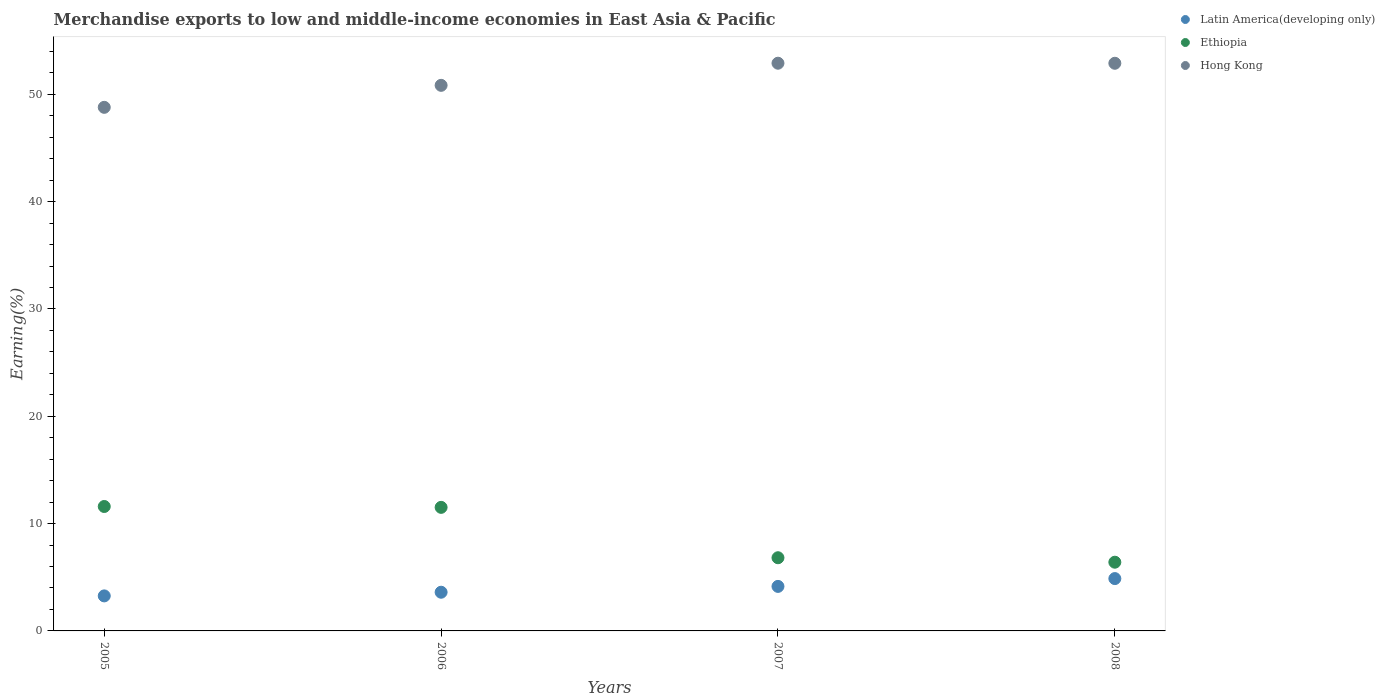What is the percentage of amount earned from merchandise exports in Ethiopia in 2006?
Keep it short and to the point. 11.51. Across all years, what is the maximum percentage of amount earned from merchandise exports in Hong Kong?
Your response must be concise. 52.91. Across all years, what is the minimum percentage of amount earned from merchandise exports in Ethiopia?
Keep it short and to the point. 6.4. In which year was the percentage of amount earned from merchandise exports in Ethiopia maximum?
Offer a very short reply. 2005. In which year was the percentage of amount earned from merchandise exports in Hong Kong minimum?
Make the answer very short. 2005. What is the total percentage of amount earned from merchandise exports in Latin America(developing only) in the graph?
Provide a short and direct response. 15.9. What is the difference between the percentage of amount earned from merchandise exports in Hong Kong in 2005 and that in 2008?
Provide a short and direct response. -4.11. What is the difference between the percentage of amount earned from merchandise exports in Ethiopia in 2005 and the percentage of amount earned from merchandise exports in Latin America(developing only) in 2008?
Keep it short and to the point. 6.72. What is the average percentage of amount earned from merchandise exports in Ethiopia per year?
Keep it short and to the point. 9.08. In the year 2005, what is the difference between the percentage of amount earned from merchandise exports in Hong Kong and percentage of amount earned from merchandise exports in Latin America(developing only)?
Offer a terse response. 45.53. In how many years, is the percentage of amount earned from merchandise exports in Hong Kong greater than 26 %?
Keep it short and to the point. 4. What is the ratio of the percentage of amount earned from merchandise exports in Hong Kong in 2005 to that in 2006?
Make the answer very short. 0.96. Is the percentage of amount earned from merchandise exports in Hong Kong in 2005 less than that in 2006?
Your response must be concise. Yes. What is the difference between the highest and the second highest percentage of amount earned from merchandise exports in Hong Kong?
Give a very brief answer. 0.01. What is the difference between the highest and the lowest percentage of amount earned from merchandise exports in Latin America(developing only)?
Provide a short and direct response. 1.61. In how many years, is the percentage of amount earned from merchandise exports in Latin America(developing only) greater than the average percentage of amount earned from merchandise exports in Latin America(developing only) taken over all years?
Your answer should be compact. 2. Is the percentage of amount earned from merchandise exports in Hong Kong strictly less than the percentage of amount earned from merchandise exports in Ethiopia over the years?
Give a very brief answer. No. How many dotlines are there?
Your response must be concise. 3. How many years are there in the graph?
Offer a very short reply. 4. Does the graph contain any zero values?
Offer a terse response. No. Does the graph contain grids?
Offer a very short reply. No. How are the legend labels stacked?
Provide a short and direct response. Vertical. What is the title of the graph?
Make the answer very short. Merchandise exports to low and middle-income economies in East Asia & Pacific. What is the label or title of the X-axis?
Provide a short and direct response. Years. What is the label or title of the Y-axis?
Provide a succinct answer. Earning(%). What is the Earning(%) in Latin America(developing only) in 2005?
Offer a terse response. 3.26. What is the Earning(%) in Ethiopia in 2005?
Keep it short and to the point. 11.6. What is the Earning(%) in Hong Kong in 2005?
Keep it short and to the point. 48.79. What is the Earning(%) of Latin America(developing only) in 2006?
Provide a short and direct response. 3.61. What is the Earning(%) in Ethiopia in 2006?
Give a very brief answer. 11.51. What is the Earning(%) of Hong Kong in 2006?
Give a very brief answer. 50.84. What is the Earning(%) of Latin America(developing only) in 2007?
Your answer should be compact. 4.15. What is the Earning(%) of Ethiopia in 2007?
Give a very brief answer. 6.82. What is the Earning(%) of Hong Kong in 2007?
Provide a short and direct response. 52.91. What is the Earning(%) in Latin America(developing only) in 2008?
Your answer should be very brief. 4.88. What is the Earning(%) of Ethiopia in 2008?
Offer a very short reply. 6.4. What is the Earning(%) in Hong Kong in 2008?
Offer a terse response. 52.9. Across all years, what is the maximum Earning(%) of Latin America(developing only)?
Your response must be concise. 4.88. Across all years, what is the maximum Earning(%) in Ethiopia?
Provide a succinct answer. 11.6. Across all years, what is the maximum Earning(%) in Hong Kong?
Provide a succinct answer. 52.91. Across all years, what is the minimum Earning(%) of Latin America(developing only)?
Keep it short and to the point. 3.26. Across all years, what is the minimum Earning(%) of Ethiopia?
Provide a succinct answer. 6.4. Across all years, what is the minimum Earning(%) of Hong Kong?
Provide a short and direct response. 48.79. What is the total Earning(%) in Latin America(developing only) in the graph?
Your answer should be very brief. 15.9. What is the total Earning(%) in Ethiopia in the graph?
Your answer should be very brief. 36.33. What is the total Earning(%) of Hong Kong in the graph?
Ensure brevity in your answer.  205.44. What is the difference between the Earning(%) of Latin America(developing only) in 2005 and that in 2006?
Give a very brief answer. -0.34. What is the difference between the Earning(%) in Ethiopia in 2005 and that in 2006?
Provide a short and direct response. 0.08. What is the difference between the Earning(%) of Hong Kong in 2005 and that in 2006?
Your answer should be very brief. -2.05. What is the difference between the Earning(%) in Latin America(developing only) in 2005 and that in 2007?
Ensure brevity in your answer.  -0.88. What is the difference between the Earning(%) in Ethiopia in 2005 and that in 2007?
Keep it short and to the point. 4.78. What is the difference between the Earning(%) in Hong Kong in 2005 and that in 2007?
Ensure brevity in your answer.  -4.11. What is the difference between the Earning(%) of Latin America(developing only) in 2005 and that in 2008?
Your answer should be very brief. -1.61. What is the difference between the Earning(%) in Ethiopia in 2005 and that in 2008?
Ensure brevity in your answer.  5.19. What is the difference between the Earning(%) of Hong Kong in 2005 and that in 2008?
Your answer should be compact. -4.11. What is the difference between the Earning(%) of Latin America(developing only) in 2006 and that in 2007?
Ensure brevity in your answer.  -0.54. What is the difference between the Earning(%) of Ethiopia in 2006 and that in 2007?
Provide a succinct answer. 4.7. What is the difference between the Earning(%) in Hong Kong in 2006 and that in 2007?
Give a very brief answer. -2.06. What is the difference between the Earning(%) of Latin America(developing only) in 2006 and that in 2008?
Keep it short and to the point. -1.27. What is the difference between the Earning(%) in Ethiopia in 2006 and that in 2008?
Ensure brevity in your answer.  5.11. What is the difference between the Earning(%) of Hong Kong in 2006 and that in 2008?
Your answer should be very brief. -2.06. What is the difference between the Earning(%) in Latin America(developing only) in 2007 and that in 2008?
Provide a succinct answer. -0.73. What is the difference between the Earning(%) in Ethiopia in 2007 and that in 2008?
Your answer should be very brief. 0.42. What is the difference between the Earning(%) of Hong Kong in 2007 and that in 2008?
Make the answer very short. 0.01. What is the difference between the Earning(%) of Latin America(developing only) in 2005 and the Earning(%) of Ethiopia in 2006?
Provide a short and direct response. -8.25. What is the difference between the Earning(%) of Latin America(developing only) in 2005 and the Earning(%) of Hong Kong in 2006?
Ensure brevity in your answer.  -47.58. What is the difference between the Earning(%) of Ethiopia in 2005 and the Earning(%) of Hong Kong in 2006?
Provide a succinct answer. -39.25. What is the difference between the Earning(%) in Latin America(developing only) in 2005 and the Earning(%) in Ethiopia in 2007?
Give a very brief answer. -3.56. What is the difference between the Earning(%) of Latin America(developing only) in 2005 and the Earning(%) of Hong Kong in 2007?
Ensure brevity in your answer.  -49.64. What is the difference between the Earning(%) in Ethiopia in 2005 and the Earning(%) in Hong Kong in 2007?
Offer a very short reply. -41.31. What is the difference between the Earning(%) of Latin America(developing only) in 2005 and the Earning(%) of Ethiopia in 2008?
Provide a succinct answer. -3.14. What is the difference between the Earning(%) of Latin America(developing only) in 2005 and the Earning(%) of Hong Kong in 2008?
Provide a succinct answer. -49.64. What is the difference between the Earning(%) in Ethiopia in 2005 and the Earning(%) in Hong Kong in 2008?
Your answer should be compact. -41.3. What is the difference between the Earning(%) in Latin America(developing only) in 2006 and the Earning(%) in Ethiopia in 2007?
Provide a succinct answer. -3.21. What is the difference between the Earning(%) of Latin America(developing only) in 2006 and the Earning(%) of Hong Kong in 2007?
Your answer should be compact. -49.3. What is the difference between the Earning(%) in Ethiopia in 2006 and the Earning(%) in Hong Kong in 2007?
Your answer should be very brief. -41.39. What is the difference between the Earning(%) of Latin America(developing only) in 2006 and the Earning(%) of Ethiopia in 2008?
Ensure brevity in your answer.  -2.8. What is the difference between the Earning(%) of Latin America(developing only) in 2006 and the Earning(%) of Hong Kong in 2008?
Offer a terse response. -49.29. What is the difference between the Earning(%) of Ethiopia in 2006 and the Earning(%) of Hong Kong in 2008?
Your response must be concise. -41.38. What is the difference between the Earning(%) of Latin America(developing only) in 2007 and the Earning(%) of Ethiopia in 2008?
Offer a terse response. -2.25. What is the difference between the Earning(%) in Latin America(developing only) in 2007 and the Earning(%) in Hong Kong in 2008?
Offer a very short reply. -48.75. What is the difference between the Earning(%) of Ethiopia in 2007 and the Earning(%) of Hong Kong in 2008?
Give a very brief answer. -46.08. What is the average Earning(%) in Latin America(developing only) per year?
Your answer should be very brief. 3.97. What is the average Earning(%) of Ethiopia per year?
Offer a terse response. 9.08. What is the average Earning(%) of Hong Kong per year?
Offer a very short reply. 51.36. In the year 2005, what is the difference between the Earning(%) in Latin America(developing only) and Earning(%) in Ethiopia?
Your answer should be very brief. -8.33. In the year 2005, what is the difference between the Earning(%) of Latin America(developing only) and Earning(%) of Hong Kong?
Offer a very short reply. -45.53. In the year 2005, what is the difference between the Earning(%) of Ethiopia and Earning(%) of Hong Kong?
Make the answer very short. -37.2. In the year 2006, what is the difference between the Earning(%) of Latin America(developing only) and Earning(%) of Ethiopia?
Give a very brief answer. -7.91. In the year 2006, what is the difference between the Earning(%) in Latin America(developing only) and Earning(%) in Hong Kong?
Ensure brevity in your answer.  -47.24. In the year 2006, what is the difference between the Earning(%) in Ethiopia and Earning(%) in Hong Kong?
Your answer should be very brief. -39.33. In the year 2007, what is the difference between the Earning(%) in Latin America(developing only) and Earning(%) in Ethiopia?
Ensure brevity in your answer.  -2.67. In the year 2007, what is the difference between the Earning(%) in Latin America(developing only) and Earning(%) in Hong Kong?
Keep it short and to the point. -48.76. In the year 2007, what is the difference between the Earning(%) of Ethiopia and Earning(%) of Hong Kong?
Provide a short and direct response. -46.09. In the year 2008, what is the difference between the Earning(%) in Latin America(developing only) and Earning(%) in Ethiopia?
Provide a succinct answer. -1.53. In the year 2008, what is the difference between the Earning(%) of Latin America(developing only) and Earning(%) of Hong Kong?
Give a very brief answer. -48.02. In the year 2008, what is the difference between the Earning(%) in Ethiopia and Earning(%) in Hong Kong?
Ensure brevity in your answer.  -46.5. What is the ratio of the Earning(%) in Latin America(developing only) in 2005 to that in 2006?
Give a very brief answer. 0.91. What is the ratio of the Earning(%) of Hong Kong in 2005 to that in 2006?
Provide a succinct answer. 0.96. What is the ratio of the Earning(%) in Latin America(developing only) in 2005 to that in 2007?
Ensure brevity in your answer.  0.79. What is the ratio of the Earning(%) in Ethiopia in 2005 to that in 2007?
Provide a succinct answer. 1.7. What is the ratio of the Earning(%) in Hong Kong in 2005 to that in 2007?
Offer a terse response. 0.92. What is the ratio of the Earning(%) in Latin America(developing only) in 2005 to that in 2008?
Provide a short and direct response. 0.67. What is the ratio of the Earning(%) of Ethiopia in 2005 to that in 2008?
Give a very brief answer. 1.81. What is the ratio of the Earning(%) in Hong Kong in 2005 to that in 2008?
Your response must be concise. 0.92. What is the ratio of the Earning(%) in Latin America(developing only) in 2006 to that in 2007?
Ensure brevity in your answer.  0.87. What is the ratio of the Earning(%) in Ethiopia in 2006 to that in 2007?
Make the answer very short. 1.69. What is the ratio of the Earning(%) in Hong Kong in 2006 to that in 2007?
Provide a short and direct response. 0.96. What is the ratio of the Earning(%) of Latin America(developing only) in 2006 to that in 2008?
Your response must be concise. 0.74. What is the ratio of the Earning(%) in Ethiopia in 2006 to that in 2008?
Your answer should be compact. 1.8. What is the ratio of the Earning(%) in Hong Kong in 2006 to that in 2008?
Make the answer very short. 0.96. What is the ratio of the Earning(%) of Latin America(developing only) in 2007 to that in 2008?
Ensure brevity in your answer.  0.85. What is the ratio of the Earning(%) of Ethiopia in 2007 to that in 2008?
Your answer should be compact. 1.06. What is the ratio of the Earning(%) in Hong Kong in 2007 to that in 2008?
Provide a short and direct response. 1. What is the difference between the highest and the second highest Earning(%) of Latin America(developing only)?
Your response must be concise. 0.73. What is the difference between the highest and the second highest Earning(%) in Ethiopia?
Your answer should be very brief. 0.08. What is the difference between the highest and the second highest Earning(%) of Hong Kong?
Your answer should be very brief. 0.01. What is the difference between the highest and the lowest Earning(%) of Latin America(developing only)?
Offer a terse response. 1.61. What is the difference between the highest and the lowest Earning(%) in Ethiopia?
Provide a succinct answer. 5.19. What is the difference between the highest and the lowest Earning(%) of Hong Kong?
Your answer should be very brief. 4.11. 